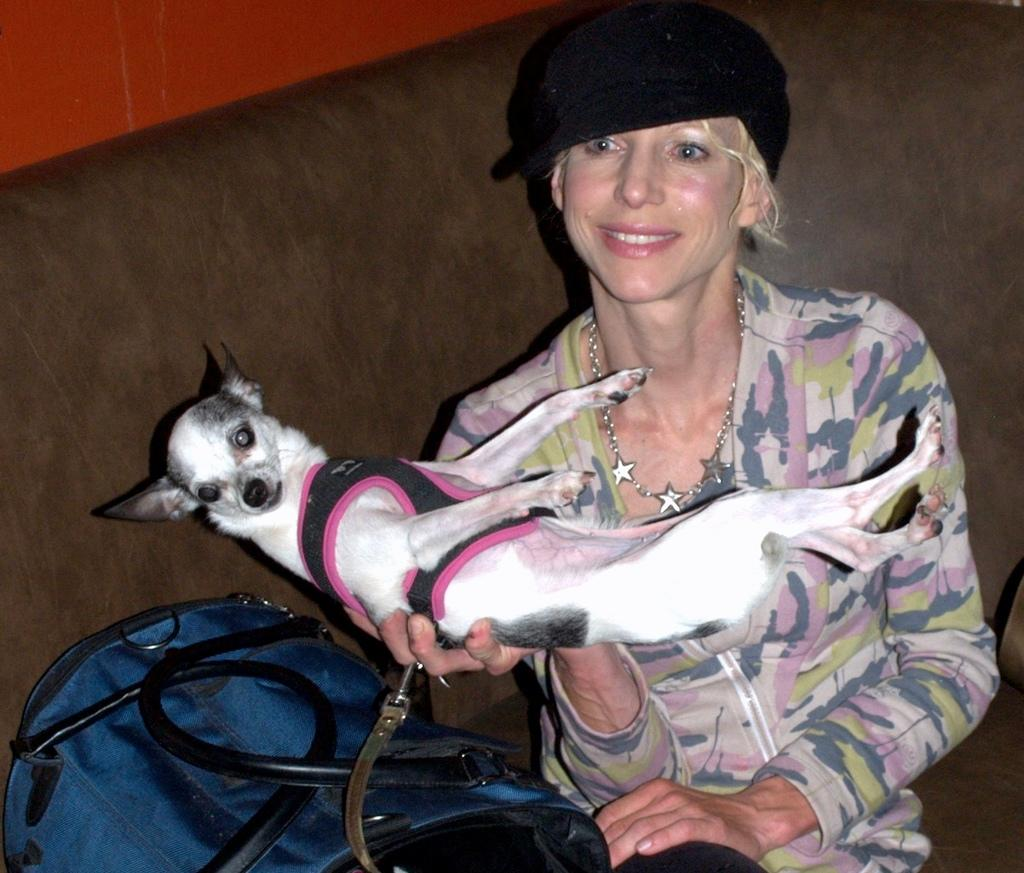Who is present in the image? There is a woman in the image. What is the woman holding? The woman is holding a dog. What else can be seen in the image? There is a bag in the image. What is the woman wearing on her head? The woman is wearing a hat. What is the woman's facial expression? The woman is smiling. What type of instrument is the woman playing in the image? There is no instrument present in the image; the woman is holding a dog. 